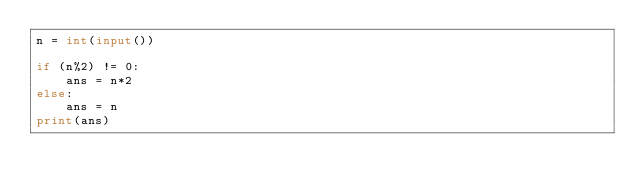Convert code to text. <code><loc_0><loc_0><loc_500><loc_500><_Python_>n = int(input())

if (n%2) != 0:
    ans = n*2
else:
    ans = n
print(ans)</code> 